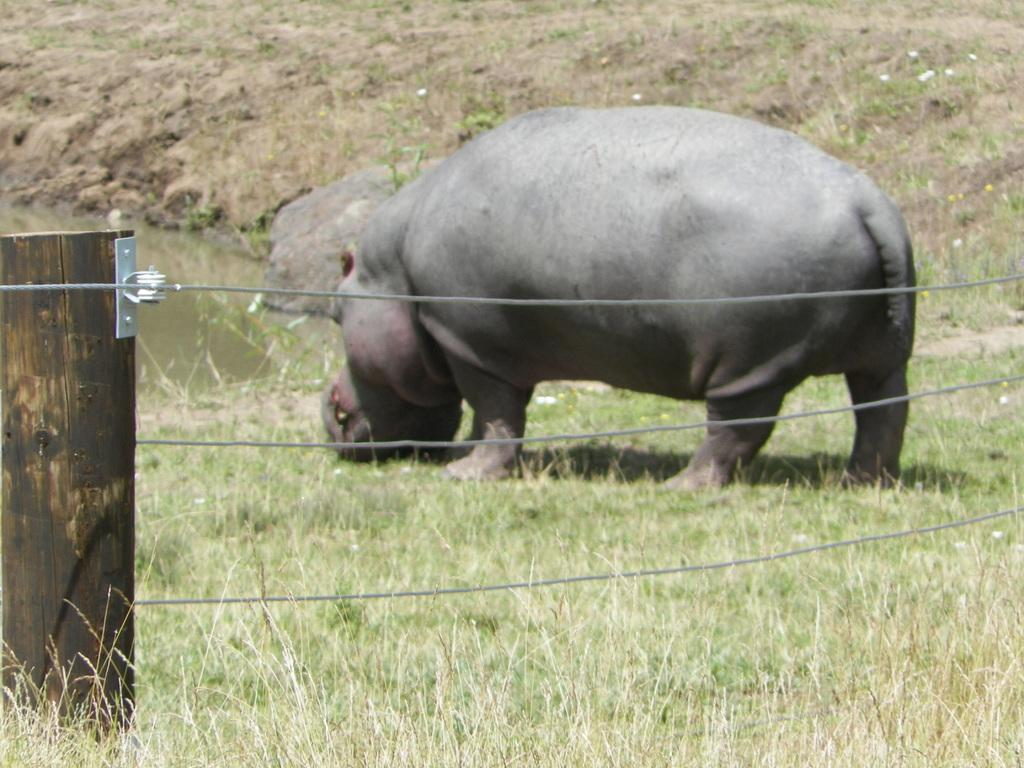What type of barrier can be seen in the image? There is a fence in the image. What animal is present on the grass in the image? There is a hippopotamus on the grass in the image. What can be seen in the background of the image? There is water visible at the left back of the image. What type of van is parked near the hippopotamus in the image? There is no van present in the image; it features a fence, a hippopotamus, and water in the background. How many members are on the team visible in the image? There is no team present in the image. 